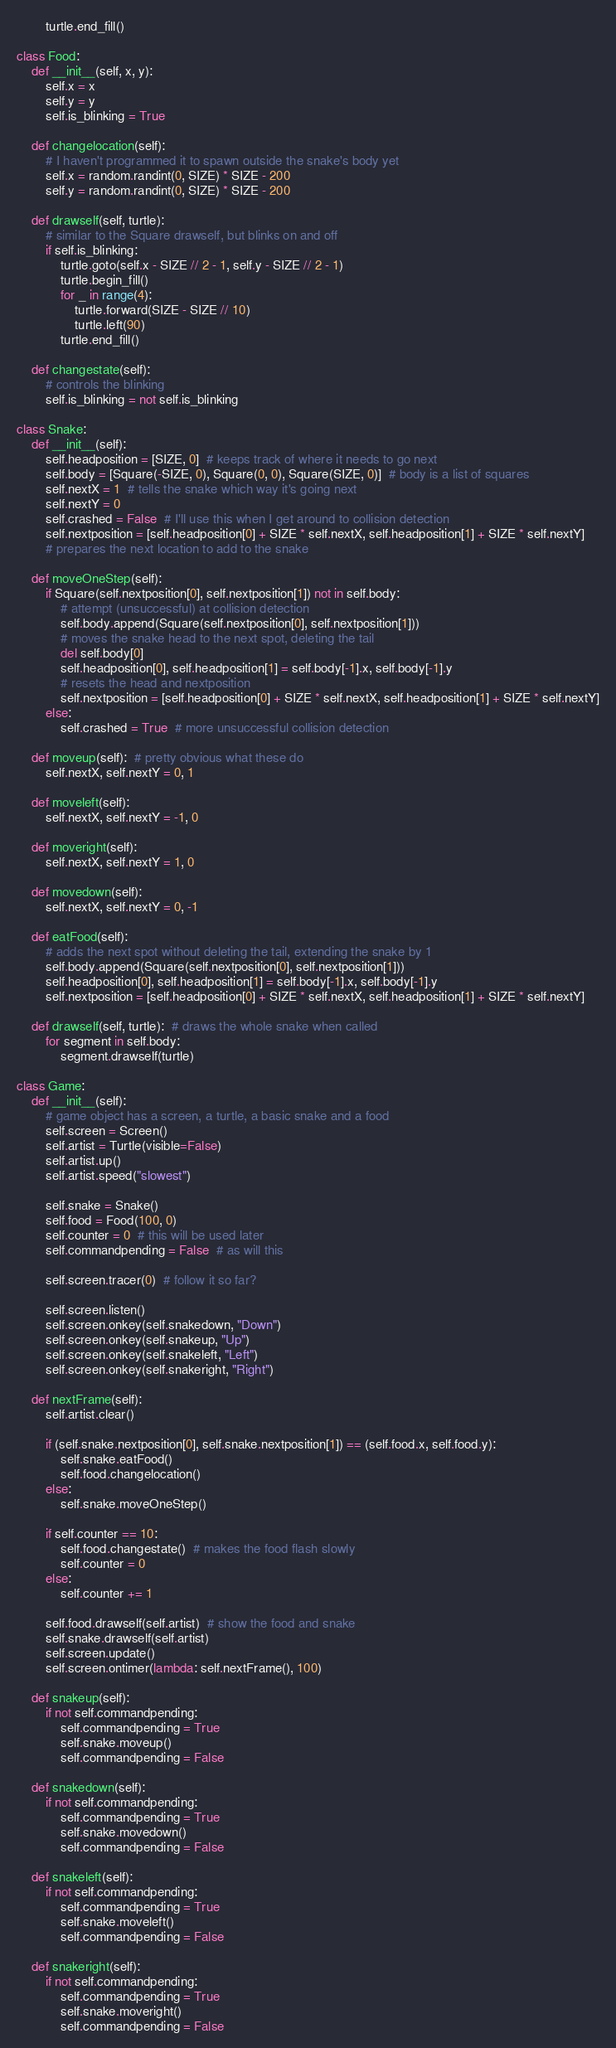Convert code to text. <code><loc_0><loc_0><loc_500><loc_500><_Python_>        turtle.end_fill()

class Food:
    def __init__(self, x, y):
        self.x = x
        self.y = y
        self.is_blinking = True

    def changelocation(self):
        # I haven't programmed it to spawn outside the snake's body yet
        self.x = random.randint(0, SIZE) * SIZE - 200
        self.y = random.randint(0, SIZE) * SIZE - 200

    def drawself(self, turtle):
        # similar to the Square drawself, but blinks on and off
        if self.is_blinking:
            turtle.goto(self.x - SIZE // 2 - 1, self.y - SIZE // 2 - 1)
            turtle.begin_fill()
            for _ in range(4):
                turtle.forward(SIZE - SIZE // 10)
                turtle.left(90)
            turtle.end_fill()

    def changestate(self):
        # controls the blinking
        self.is_blinking = not self.is_blinking

class Snake:
    def __init__(self):
        self.headposition = [SIZE, 0]  # keeps track of where it needs to go next
        self.body = [Square(-SIZE, 0), Square(0, 0), Square(SIZE, 0)]  # body is a list of squares
        self.nextX = 1  # tells the snake which way it's going next
        self.nextY = 0
        self.crashed = False  # I'll use this when I get around to collision detection
        self.nextposition = [self.headposition[0] + SIZE * self.nextX, self.headposition[1] + SIZE * self.nextY]
        # prepares the next location to add to the snake

    def moveOneStep(self):
        if Square(self.nextposition[0], self.nextposition[1]) not in self.body: 
            # attempt (unsuccessful) at collision detection
            self.body.append(Square(self.nextposition[0], self.nextposition[1])) 
            # moves the snake head to the next spot, deleting the tail
            del self.body[0]
            self.headposition[0], self.headposition[1] = self.body[-1].x, self.body[-1].y 
            # resets the head and nextposition
            self.nextposition = [self.headposition[0] + SIZE * self.nextX, self.headposition[1] + SIZE * self.nextY]
        else:
            self.crashed = True  # more unsuccessful collision detection

    def moveup(self):  # pretty obvious what these do
        self.nextX, self.nextY = 0, 1

    def moveleft(self):
        self.nextX, self.nextY = -1, 0

    def moveright(self):
        self.nextX, self.nextY = 1, 0

    def movedown(self):
        self.nextX, self.nextY = 0, -1

    def eatFood(self):
        # adds the next spot without deleting the tail, extending the snake by 1
        self.body.append(Square(self.nextposition[0], self.nextposition[1]))
        self.headposition[0], self.headposition[1] = self.body[-1].x, self.body[-1].y
        self.nextposition = [self.headposition[0] + SIZE * self.nextX, self.headposition[1] + SIZE * self.nextY]

    def drawself(self, turtle):  # draws the whole snake when called
        for segment in self.body:
            segment.drawself(turtle)

class Game:
    def __init__(self):
        # game object has a screen, a turtle, a basic snake and a food
        self.screen = Screen()
        self.artist = Turtle(visible=False)
        self.artist.up()
        self.artist.speed("slowest")

        self.snake = Snake()
        self.food = Food(100, 0)
        self.counter = 0  # this will be used later
        self.commandpending = False  # as will this

        self.screen.tracer(0)  # follow it so far?

        self.screen.listen()
        self.screen.onkey(self.snakedown, "Down")
        self.screen.onkey(self.snakeup, "Up")
        self.screen.onkey(self.snakeleft, "Left")
        self.screen.onkey(self.snakeright, "Right")

    def nextFrame(self):
        self.artist.clear()

        if (self.snake.nextposition[0], self.snake.nextposition[1]) == (self.food.x, self.food.y):
            self.snake.eatFood()
            self.food.changelocation()
        else:
            self.snake.moveOneStep()

        if self.counter == 10:
            self.food.changestate()  # makes the food flash slowly
            self.counter = 0
        else:
            self.counter += 1

        self.food.drawself(self.artist)  # show the food and snake
        self.snake.drawself(self.artist)
        self.screen.update()
        self.screen.ontimer(lambda: self.nextFrame(), 100)

    def snakeup(self):
        if not self.commandpending: 
            self.commandpending = True
            self.snake.moveup()
            self.commandpending = False

    def snakedown(self):
        if not self.commandpending:
            self.commandpending = True
            self.snake.movedown()
            self.commandpending = False

    def snakeleft(self):
        if not self.commandpending:
            self.commandpending = True
            self.snake.moveleft()
            self.commandpending = False

    def snakeright(self):
        if not self.commandpending:
            self.commandpending = True
            self.snake.moveright()
            self.commandpending = False</code> 